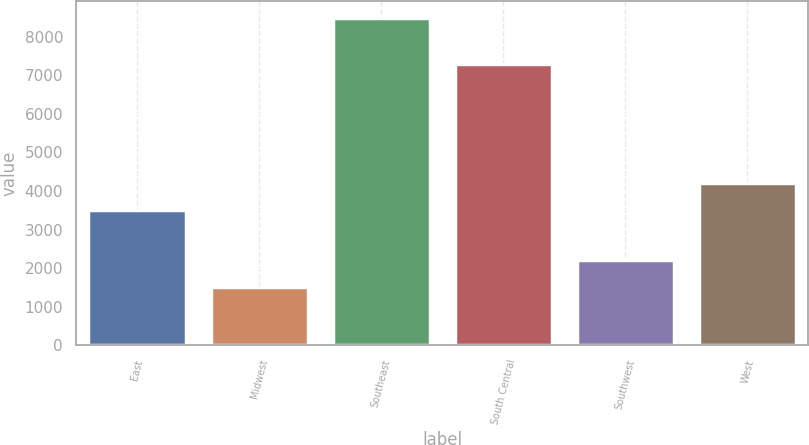Convert chart to OTSL. <chart><loc_0><loc_0><loc_500><loc_500><bar_chart><fcel>East<fcel>Midwest<fcel>Southeast<fcel>South Central<fcel>Southwest<fcel>West<nl><fcel>3500<fcel>1500<fcel>8500<fcel>7300<fcel>2200<fcel>4200<nl></chart> 